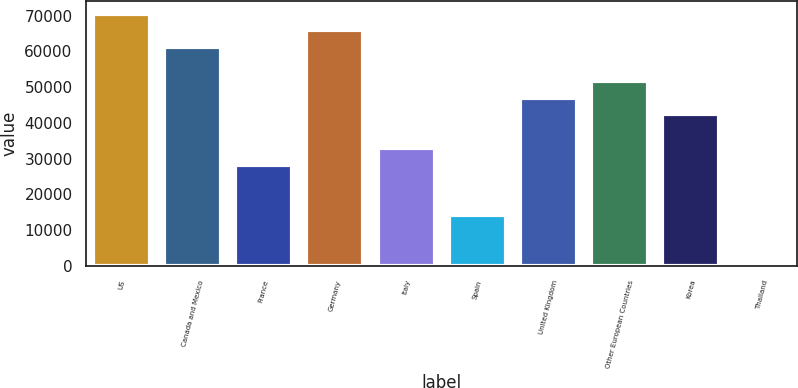Convert chart to OTSL. <chart><loc_0><loc_0><loc_500><loc_500><bar_chart><fcel>US<fcel>Canada and Mexico<fcel>France<fcel>Germany<fcel>Italy<fcel>Spain<fcel>United Kingdom<fcel>Other European Countries<fcel>Korea<fcel>Thailand<nl><fcel>70621<fcel>61218.6<fcel>28310.2<fcel>65919.8<fcel>33011.4<fcel>14206.6<fcel>47115<fcel>51816.2<fcel>42413.8<fcel>103<nl></chart> 